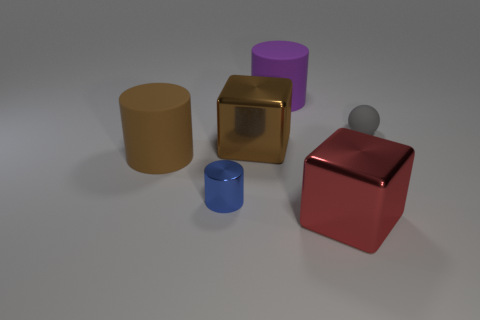Add 4 large rubber spheres. How many objects exist? 10 Subtract all spheres. How many objects are left? 5 Subtract 0 brown balls. How many objects are left? 6 Subtract all tiny gray matte balls. Subtract all tiny gray things. How many objects are left? 4 Add 1 small cylinders. How many small cylinders are left? 2 Add 5 tiny matte spheres. How many tiny matte spheres exist? 6 